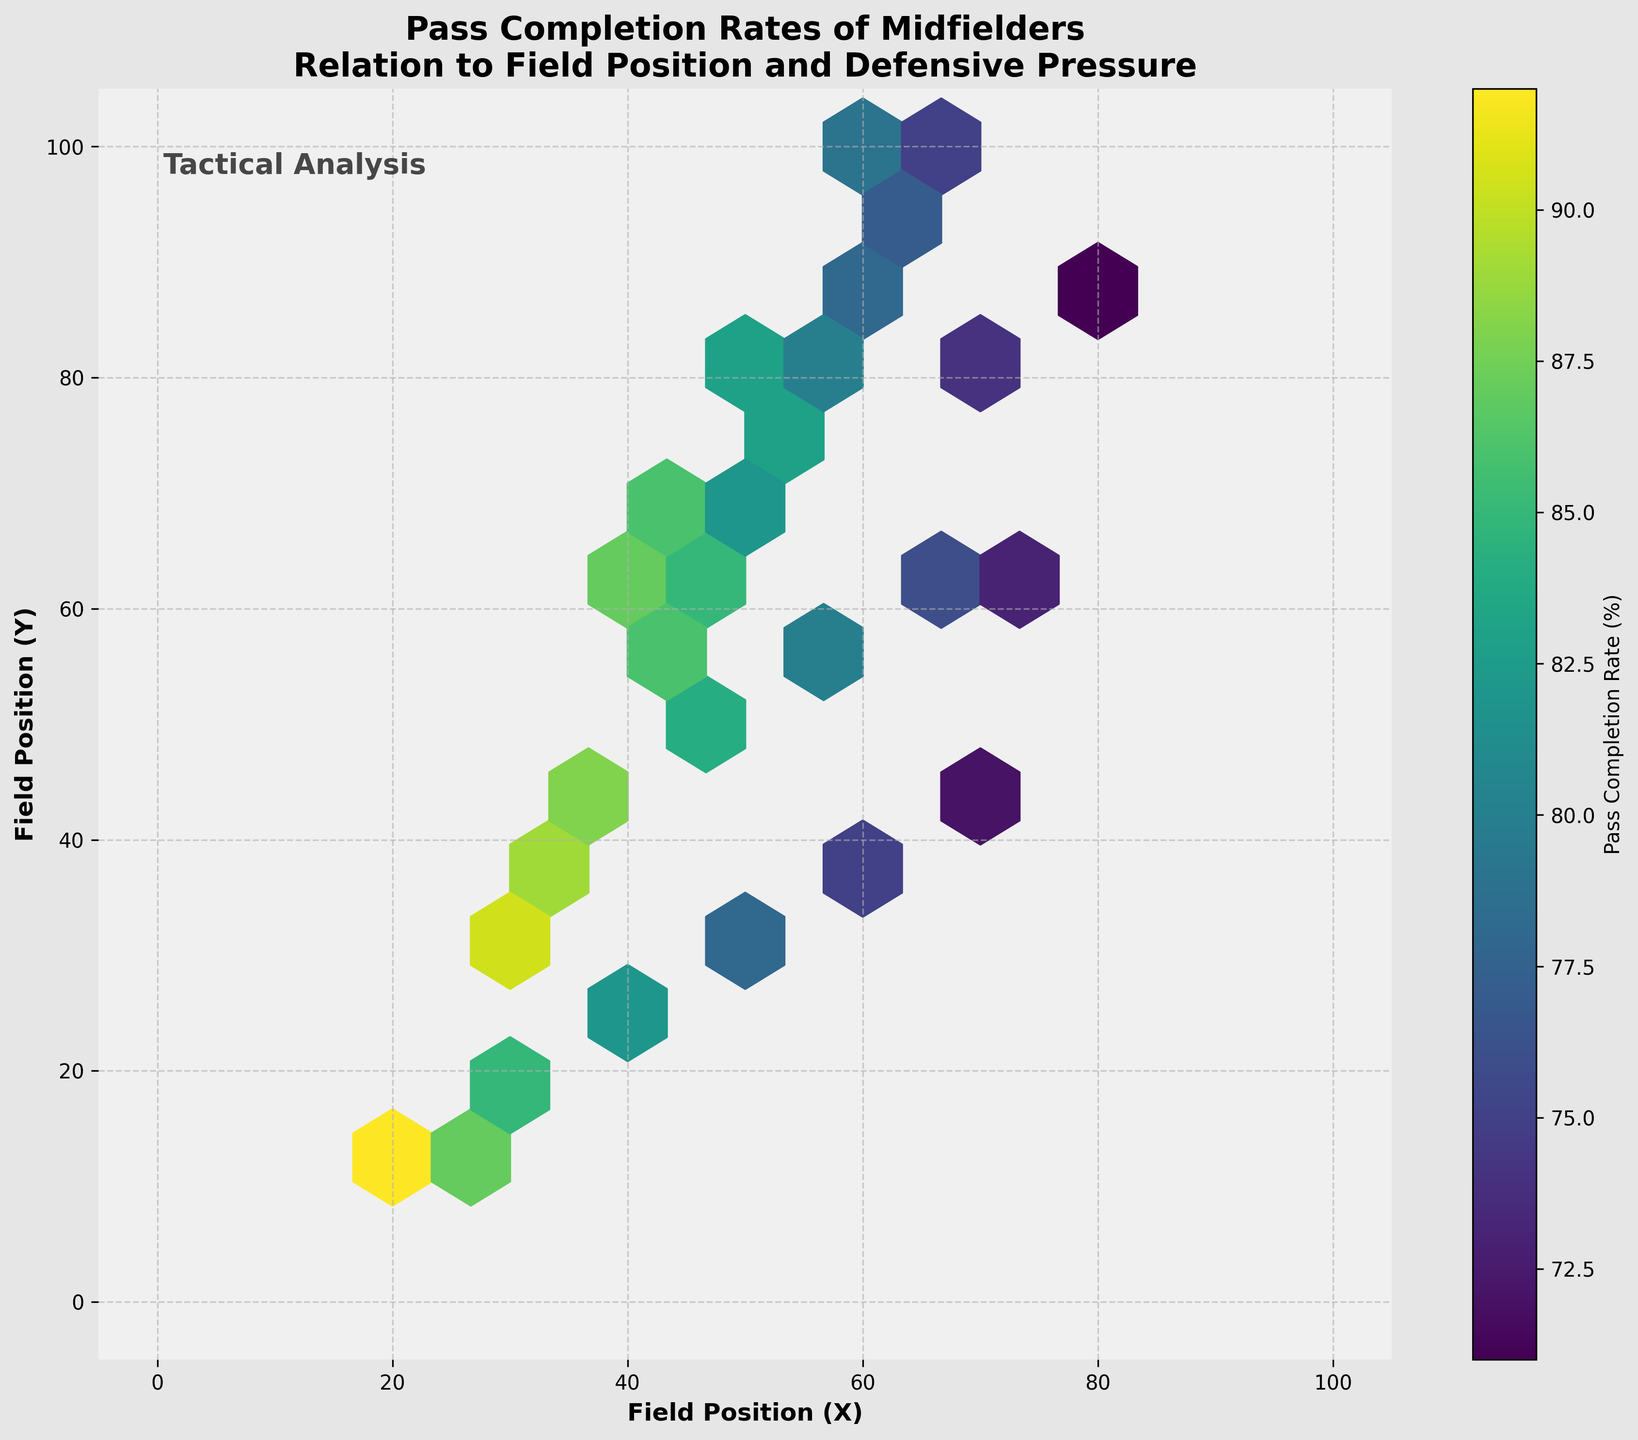How many hexagonal bins are present in the plot? Visual examination reveals the number of hexagonal bins representing different field positions and pass completion rates. Count each hexagon in the plot.
Answer: 15 What is the title of the plot? The title is prominently displayed at the top of the plot.
Answer: “Pass Completion Rates of Midfielders: Relation to Field Position and Defensive Pressure” What is the range of the pass completion rates in the color bar? Look at the minimum and maximum values indicated on the color bar located next to the plot.
Answer: 70% to 92% Is there a difference in the density of hexagons between the left and right sides of the plot? Compare the density of hexagons visually between the left and right halves of the plot.
Answer: Yes, the right side appears denser Which field position area has the highest average pass completion rate according to the color distribution? Identify the lightest hexagons, as the lighter the color, the higher the pass completion rate; find their corresponding field positions.
Answer: Top-left area What color represents a 90% pass completion rate on the plot? Observe the color bar and locate the color that aligns with 90%.
Answer: Light yellow Which areas of the field generally have pass completion rates above 85%? Identify regions where hexagons have colors indicating pass rates above 85%, as conveyed by the color bar.
Answer: Mostly in the lower-left and middle-left areas What general trend is observed between field position and pass completion rates? Analyze the gradient of colors from one end of the field to the other and observe the overall trend.
Answer: Pass completion decreases as field position moves to the right and upward Are there areas of the plot where defensive pressure seems to significantly impact pass completion rates? Look for areas with the darkest hexagon colors (lower completion rates) and their field positions.
Answer: Upper-right areas 